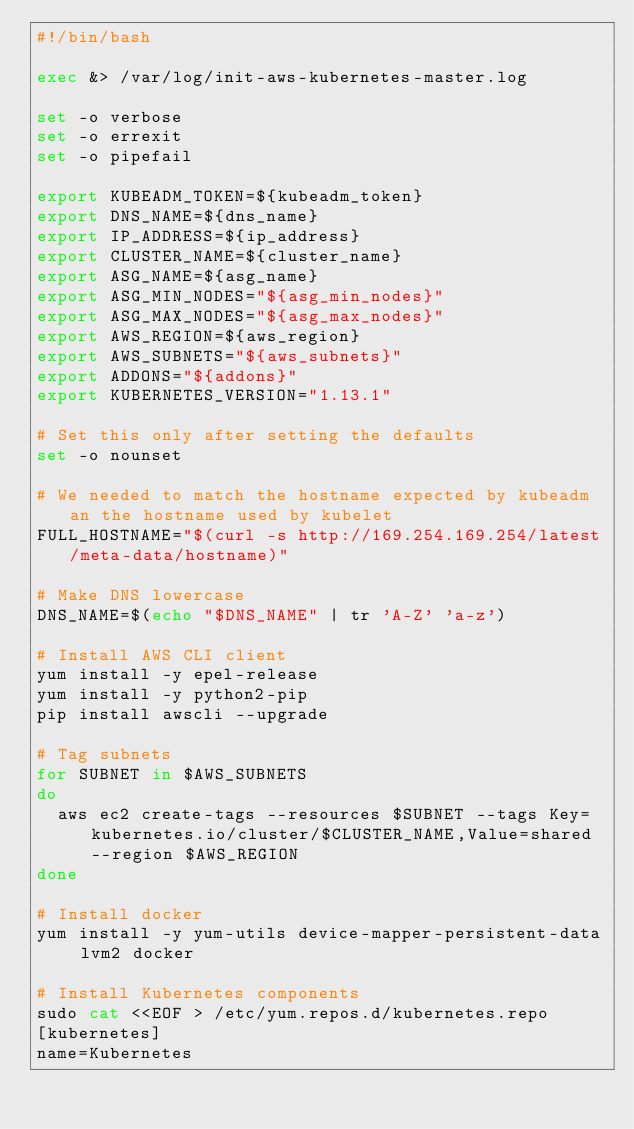Convert code to text. <code><loc_0><loc_0><loc_500><loc_500><_Bash_>#!/bin/bash

exec &> /var/log/init-aws-kubernetes-master.log

set -o verbose
set -o errexit
set -o pipefail

export KUBEADM_TOKEN=${kubeadm_token}
export DNS_NAME=${dns_name}
export IP_ADDRESS=${ip_address}
export CLUSTER_NAME=${cluster_name}
export ASG_NAME=${asg_name}
export ASG_MIN_NODES="${asg_min_nodes}"
export ASG_MAX_NODES="${asg_max_nodes}"
export AWS_REGION=${aws_region}
export AWS_SUBNETS="${aws_subnets}"
export ADDONS="${addons}"
export KUBERNETES_VERSION="1.13.1"

# Set this only after setting the defaults
set -o nounset

# We needed to match the hostname expected by kubeadm an the hostname used by kubelet
FULL_HOSTNAME="$(curl -s http://169.254.169.254/latest/meta-data/hostname)"

# Make DNS lowercase
DNS_NAME=$(echo "$DNS_NAME" | tr 'A-Z' 'a-z')

# Install AWS CLI client
yum install -y epel-release
yum install -y python2-pip
pip install awscli --upgrade

# Tag subnets
for SUBNET in $AWS_SUBNETS
do
  aws ec2 create-tags --resources $SUBNET --tags Key=kubernetes.io/cluster/$CLUSTER_NAME,Value=shared --region $AWS_REGION
done

# Install docker
yum install -y yum-utils device-mapper-persistent-data lvm2 docker

# Install Kubernetes components
sudo cat <<EOF > /etc/yum.repos.d/kubernetes.repo
[kubernetes]
name=Kubernetes</code> 